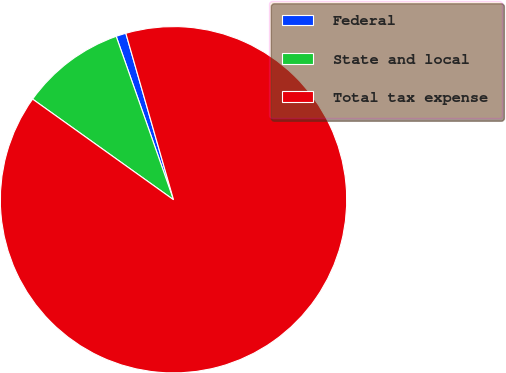Convert chart. <chart><loc_0><loc_0><loc_500><loc_500><pie_chart><fcel>Federal<fcel>State and local<fcel>Total tax expense<nl><fcel>0.93%<fcel>9.76%<fcel>89.31%<nl></chart> 